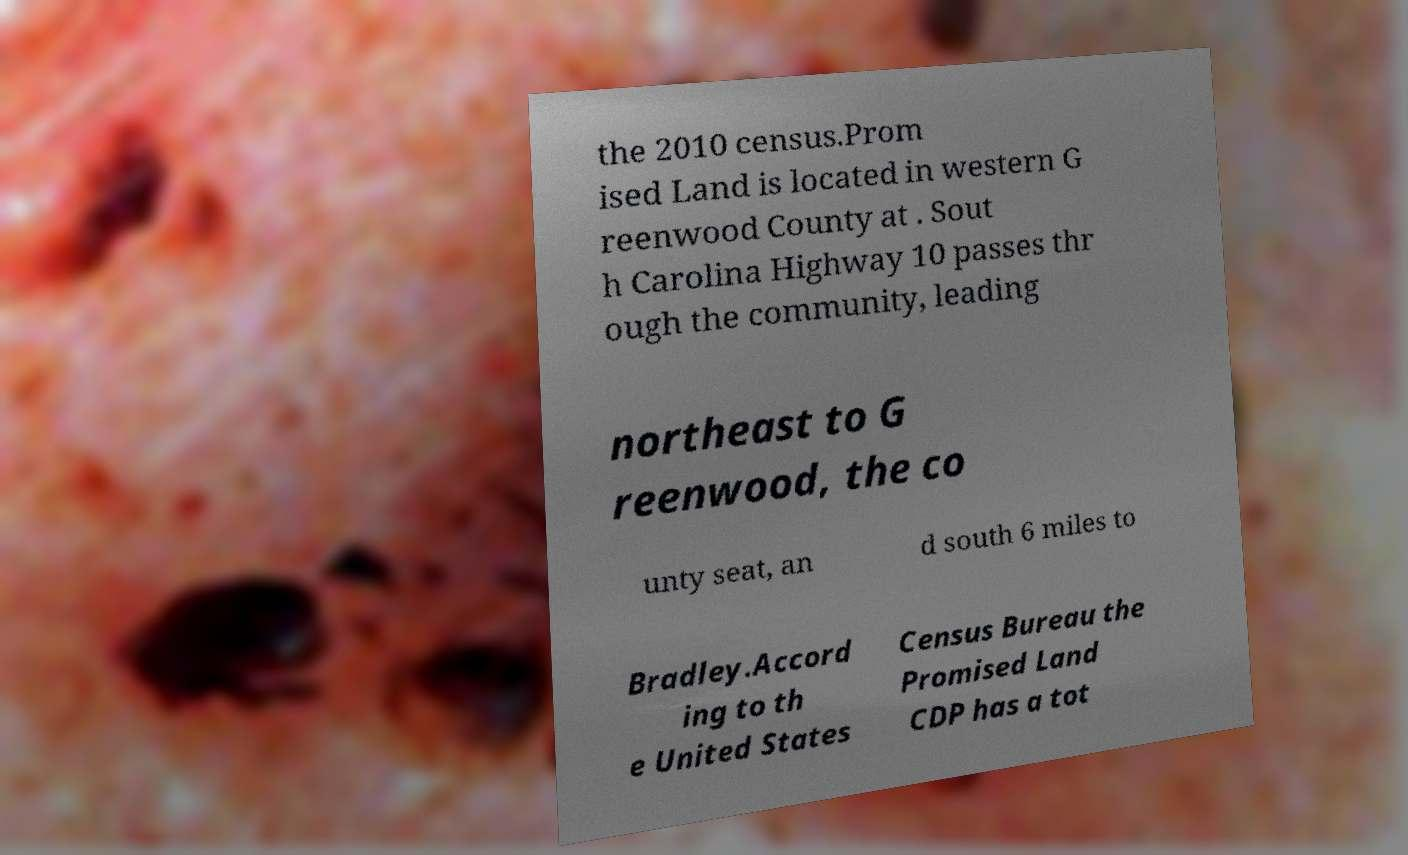Can you read and provide the text displayed in the image?This photo seems to have some interesting text. Can you extract and type it out for me? the 2010 census.Prom ised Land is located in western G reenwood County at . Sout h Carolina Highway 10 passes thr ough the community, leading northeast to G reenwood, the co unty seat, an d south 6 miles to Bradley.Accord ing to th e United States Census Bureau the Promised Land CDP has a tot 